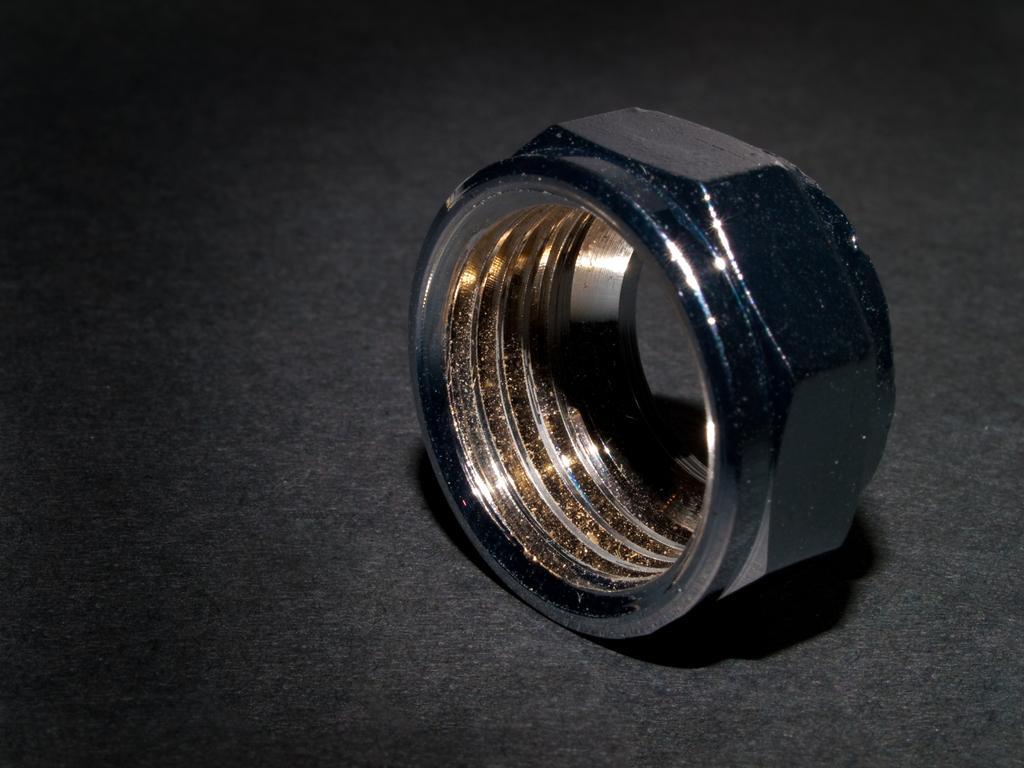In one or two sentences, can you explain what this image depicts? In this image we can see a bolt on the surface. 